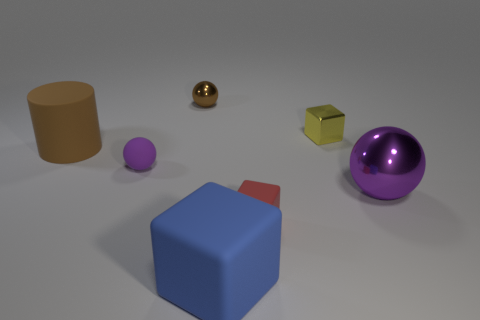Subtract all metal blocks. How many blocks are left? 2 Subtract all purple spheres. How many were subtracted if there are1purple spheres left? 1 Subtract 3 cubes. How many cubes are left? 0 Subtract all green spheres. Subtract all purple cubes. How many spheres are left? 3 Subtract all yellow cylinders. How many yellow cubes are left? 1 Subtract all small blue rubber spheres. Subtract all red blocks. How many objects are left? 6 Add 5 brown rubber cylinders. How many brown rubber cylinders are left? 6 Add 7 spheres. How many spheres exist? 10 Add 3 small purple rubber objects. How many objects exist? 10 Subtract all brown spheres. How many spheres are left? 2 